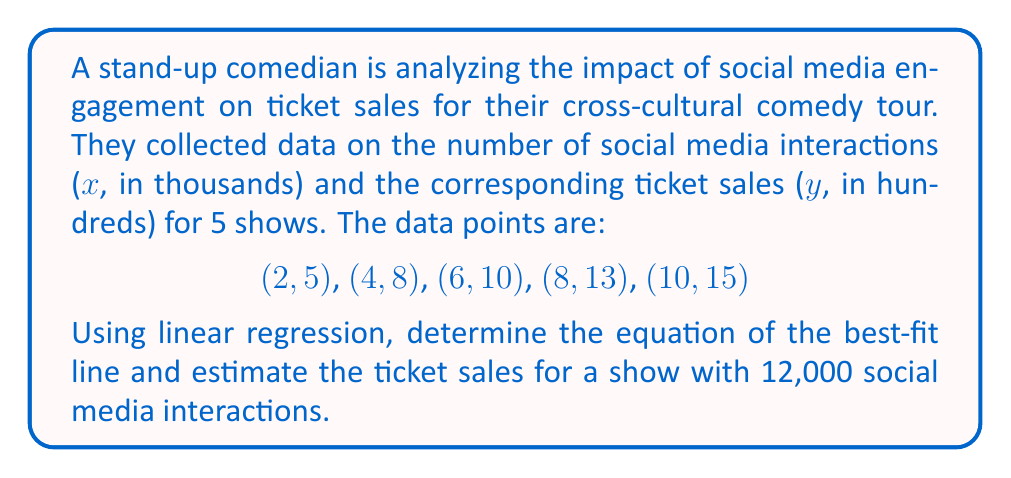Solve this math problem. 1. To find the linear regression equation, we need to calculate the slope (m) and y-intercept (b) of the best-fit line.

2. Calculate the means of x and y:
   $\bar{x} = \frac{2 + 4 + 6 + 8 + 10}{5} = 6$
   $\bar{y} = \frac{5 + 8 + 10 + 13 + 15}{5} = 10.2$

3. Calculate the slope (m):
   $m = \frac{\sum(x_i - \bar{x})(y_i - \bar{y})}{\sum(x_i - \bar{x})^2}$

   $m = \frac{(-4)(-5.2) + (-2)(-2.2) + (0)(-0.2) + (2)(2.8) + (4)(4.8)}{(-4)^2 + (-2)^2 + (0)^2 + (2)^2 + (4)^2}$

   $m = \frac{20.8 + 4.4 + 0 + 5.6 + 19.2}{16 + 4 + 0 + 4 + 16}$

   $m = \frac{50}{40} = 1.25$

4. Calculate the y-intercept (b):
   $b = \bar{y} - m\bar{x} = 10.2 - 1.25(6) = 2.7$

5. The linear regression equation is:
   $y = 1.25x + 2.7$

6. To estimate ticket sales for 12,000 social media interactions:
   $x = 12$ (since x is in thousands)
   $y = 1.25(12) + 2.7 = 17.7$

This means an estimated 1,770 tickets would be sold (since y is in hundreds).
Answer: $y = 1.25x + 2.7$; 1,770 tickets 